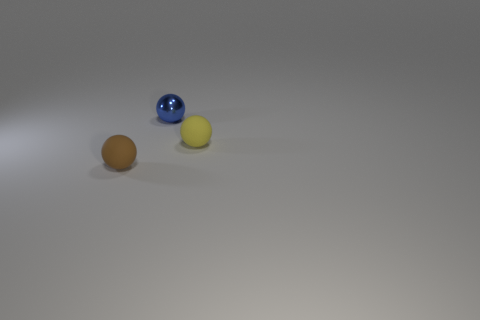Add 3 tiny blue shiny things. How many objects exist? 6 Subtract 0 purple cubes. How many objects are left? 3 Subtract all brown things. Subtract all tiny brown cylinders. How many objects are left? 2 Add 3 tiny metallic spheres. How many tiny metallic spheres are left? 4 Add 3 large green shiny things. How many large green shiny things exist? 3 